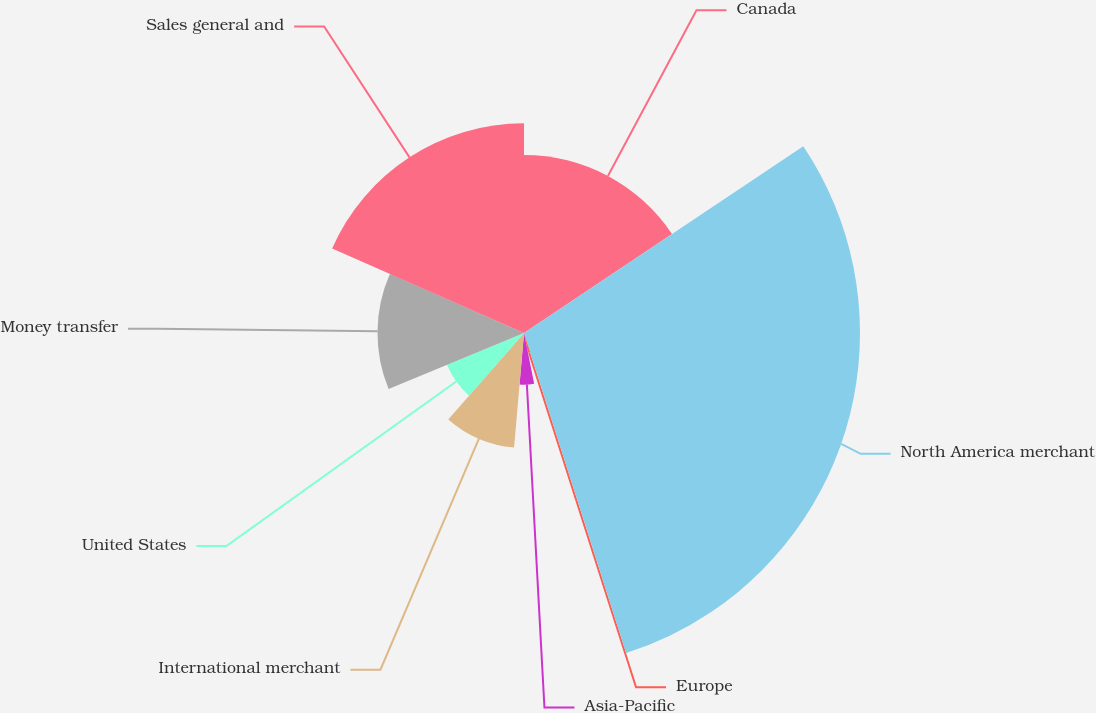Convert chart to OTSL. <chart><loc_0><loc_0><loc_500><loc_500><pie_chart><fcel>Canada<fcel>North America merchant<fcel>Europe<fcel>Asia-Pacific<fcel>International merchant<fcel>United States<fcel>Money transfer<fcel>Sales general and<nl><fcel>15.62%<fcel>29.47%<fcel>1.76%<fcel>4.53%<fcel>10.08%<fcel>7.31%<fcel>12.85%<fcel>18.39%<nl></chart> 